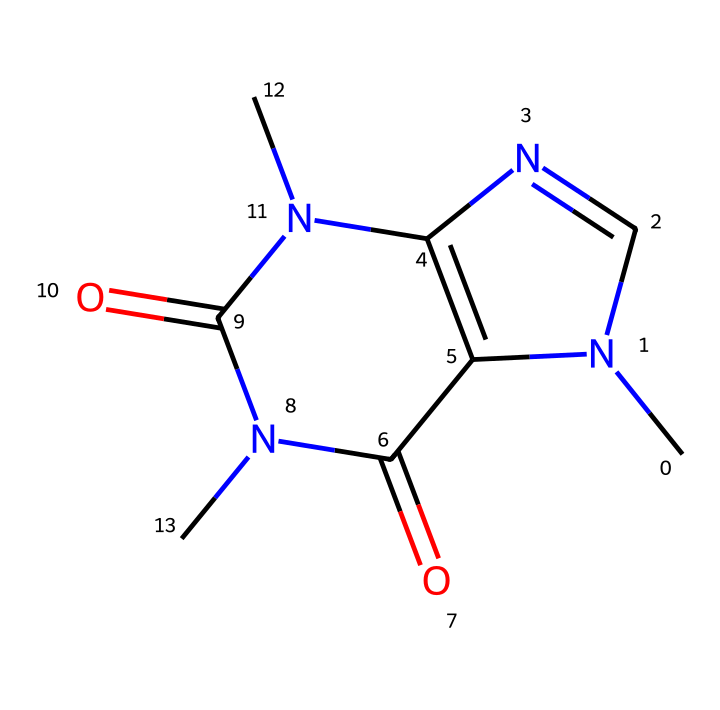What is the molecular formula of this chemical? By analyzing the structure represented by the SMILES, we can count the number of each type of atom present. In this case, we recognize that there are 6 Carbon atoms, 6 Nitrogen atoms, and 4 Oxygen atoms. Therefore, the molecular formula is C6H6N4O2.
Answer: C6H6N4O2 How many rings are present in this chemical structure? The structure shows multiple interconnected atoms, and by examining the layout, we can count that there are indeed two distinct rings in the molecular structure.
Answer: 2 What type of chemical is this compound classified as? The structure includes multiple nitrogen atoms as well as a fused ring arrangement, which identifies this compound primarily as a purine derivative, thus classifying it as a nucleobase.
Answer: nucleobase Does this chemical contain any functional groups? Looking at the diagram, we can identify that there are carbonyl (C=O) groups present, which are indicative of the presence of the amide functional group in the structure.
Answer: amide Is this chemical likely to have stimulant properties? The presence of nitrogen atoms in a bicyclic structure often points towards compounds with stimulant effects. Specifically, caffeine, deriving from similar types, is widely known for its energy-boosting properties.
Answer: Yes 